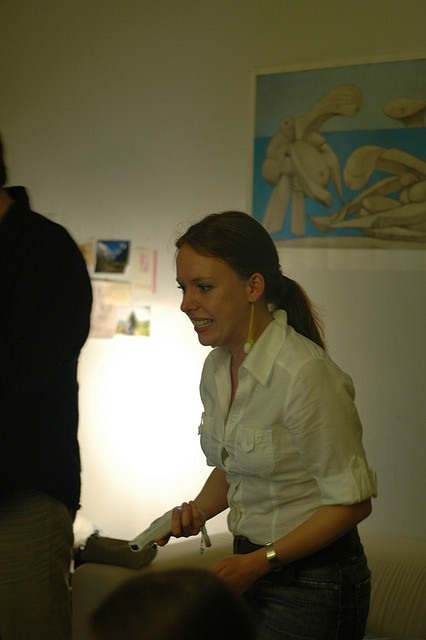Describe the objects in this image and their specific colors. I can see people in darkgreen, black, olive, and maroon tones, people in darkgreen, black, beige, and gray tones, and remote in darkgreen, olive, maroon, and black tones in this image. 